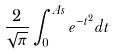<formula> <loc_0><loc_0><loc_500><loc_500>\frac { 2 } { \sqrt { \pi } } \int _ { 0 } ^ { A s } e ^ { - t ^ { 2 } } d t</formula> 